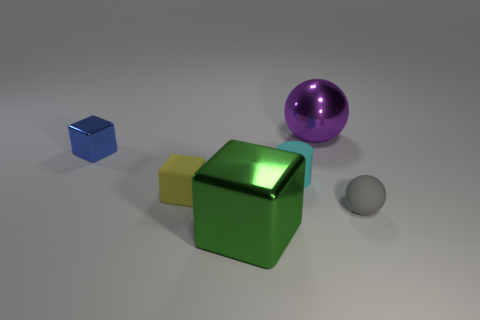How many cyan objects are the same size as the blue shiny block?
Make the answer very short. 1. There is a cube that is in front of the gray object; is it the same size as the small cyan thing?
Make the answer very short. No. What shape is the object that is to the right of the big green metal thing and in front of the small cyan matte object?
Make the answer very short. Sphere. Are there any cubes in front of the tiny gray rubber ball?
Your answer should be compact. Yes. Is there any other thing that is the same shape as the cyan thing?
Offer a terse response. No. Is the tiny blue metallic thing the same shape as the large green thing?
Provide a short and direct response. Yes. Are there an equal number of yellow things on the right side of the big green object and spheres that are in front of the matte block?
Your answer should be very brief. No. How many other objects are the same material as the large green object?
Give a very brief answer. 2. How many large things are cyan matte cylinders or blue rubber balls?
Give a very brief answer. 0. Are there an equal number of large shiny things that are in front of the yellow cube and big red matte cylinders?
Provide a short and direct response. No. 